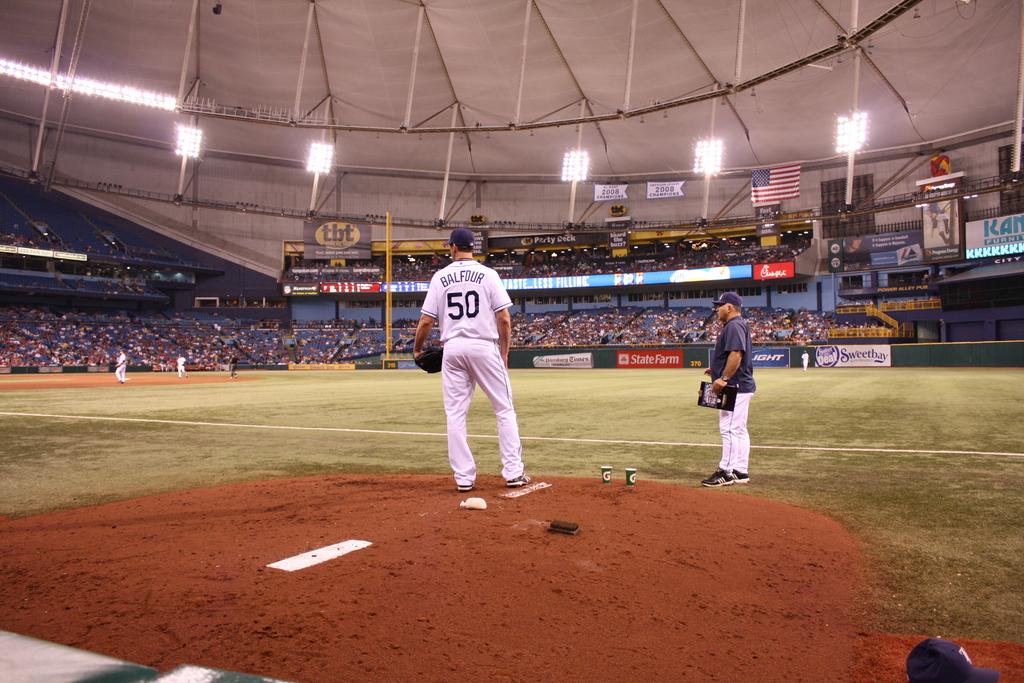Who is playing in the baseball game?
Make the answer very short. Balfour. What number is the pitcher?
Your answer should be compact. 50. 